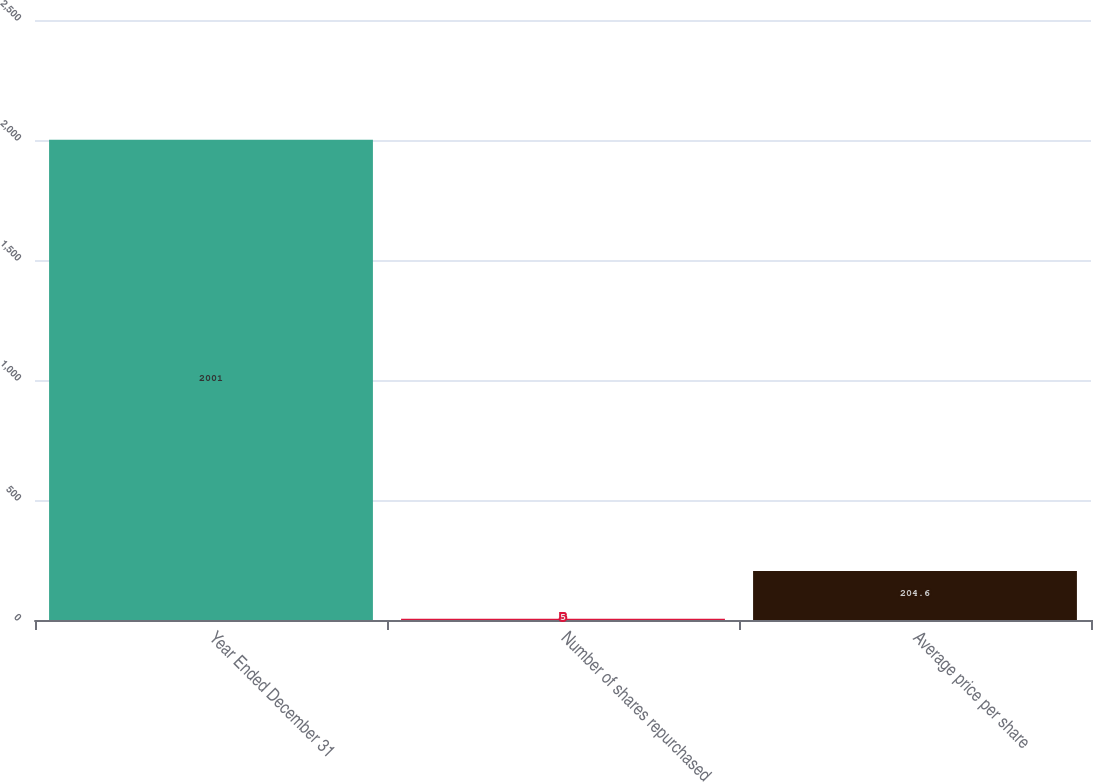Convert chart. <chart><loc_0><loc_0><loc_500><loc_500><bar_chart><fcel>Year Ended December 31<fcel>Number of shares repurchased<fcel>Average price per share<nl><fcel>2001<fcel>5<fcel>204.6<nl></chart> 